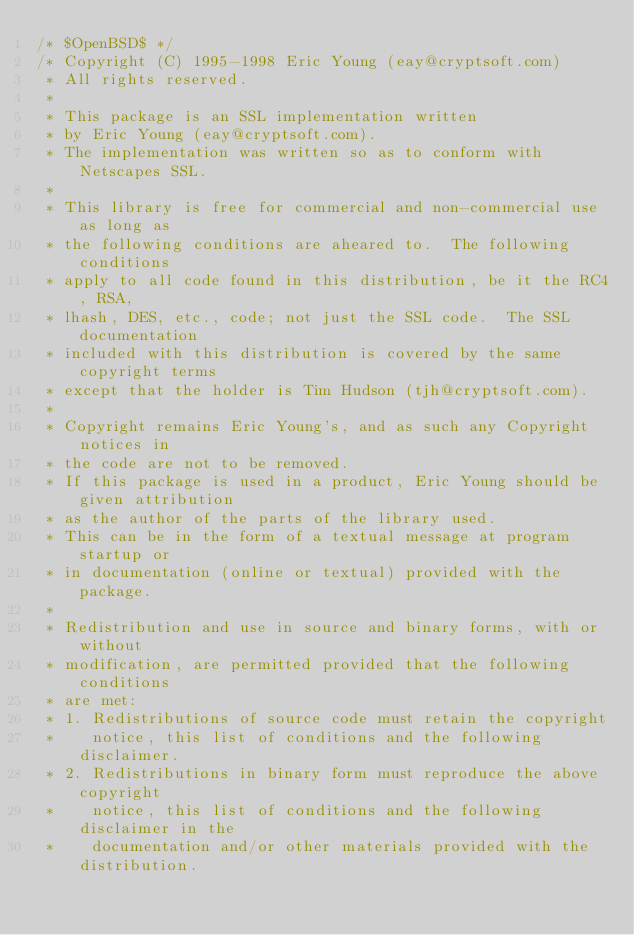<code> <loc_0><loc_0><loc_500><loc_500><_C_>/* $OpenBSD$ */
/* Copyright (C) 1995-1998 Eric Young (eay@cryptsoft.com)
 * All rights reserved.
 *
 * This package is an SSL implementation written
 * by Eric Young (eay@cryptsoft.com).
 * The implementation was written so as to conform with Netscapes SSL.
 * 
 * This library is free for commercial and non-commercial use as long as
 * the following conditions are aheared to.  The following conditions
 * apply to all code found in this distribution, be it the RC4, RSA,
 * lhash, DES, etc., code; not just the SSL code.  The SSL documentation
 * included with this distribution is covered by the same copyright terms
 * except that the holder is Tim Hudson (tjh@cryptsoft.com).
 * 
 * Copyright remains Eric Young's, and as such any Copyright notices in
 * the code are not to be removed.
 * If this package is used in a product, Eric Young should be given attribution
 * as the author of the parts of the library used.
 * This can be in the form of a textual message at program startup or
 * in documentation (online or textual) provided with the package.
 * 
 * Redistribution and use in source and binary forms, with or without
 * modification, are permitted provided that the following conditions
 * are met:
 * 1. Redistributions of source code must retain the copyright
 *    notice, this list of conditions and the following disclaimer.
 * 2. Redistributions in binary form must reproduce the above copyright
 *    notice, this list of conditions and the following disclaimer in the
 *    documentation and/or other materials provided with the distribution.</code> 